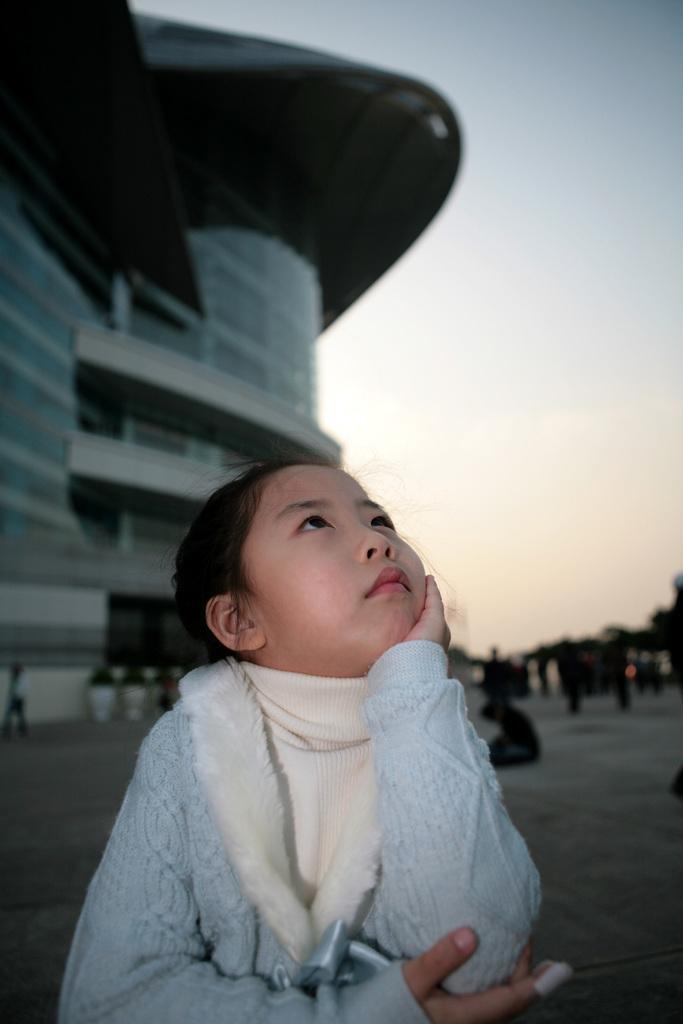How would you summarize this image in a sentence or two? In the picture I can see a girl is standing on the ground. In the background I can see a building, the sky and some other objects. The background of the image is blurred. 